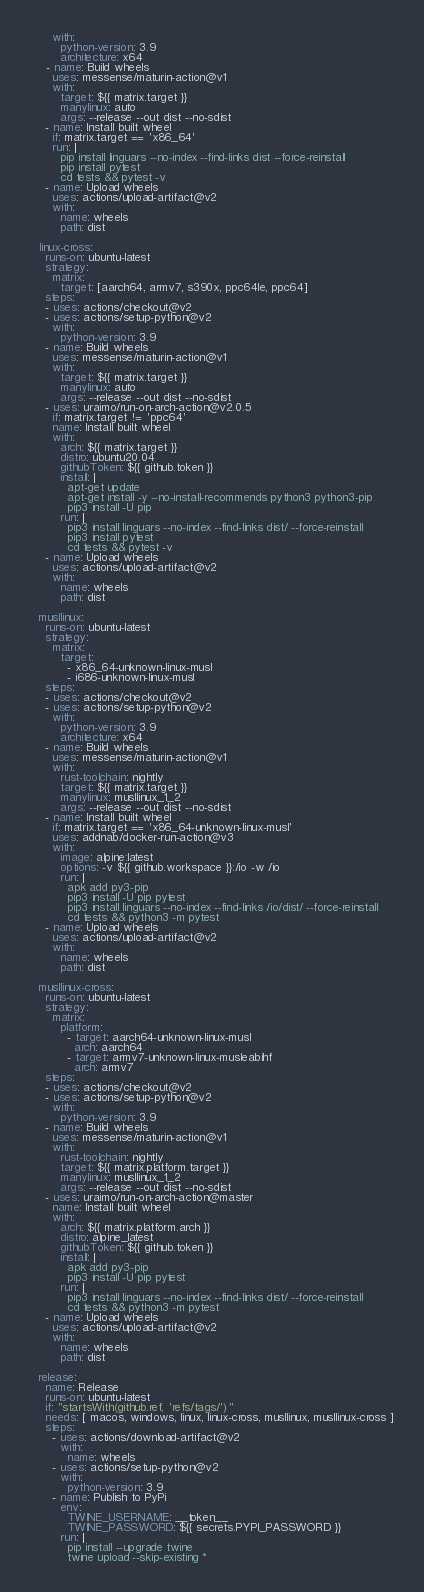Convert code to text. <code><loc_0><loc_0><loc_500><loc_500><_YAML_>      with:
        python-version: 3.9
        architecture: x64
    - name: Build wheels
      uses: messense/maturin-action@v1
      with:
        target: ${{ matrix.target }}
        manylinux: auto
        args: --release --out dist --no-sdist
    - name: Install built wheel
      if: matrix.target == 'x86_64'
      run: |
        pip install linguars --no-index --find-links dist --force-reinstall
        pip install pytest
        cd tests && pytest -v
    - name: Upload wheels
      uses: actions/upload-artifact@v2
      with:
        name: wheels
        path: dist

  linux-cross:
    runs-on: ubuntu-latest
    strategy:
      matrix:
        target: [aarch64, armv7, s390x, ppc64le, ppc64]
    steps:
    - uses: actions/checkout@v2
    - uses: actions/setup-python@v2
      with:
        python-version: 3.9
    - name: Build wheels
      uses: messense/maturin-action@v1
      with:
        target: ${{ matrix.target }}
        manylinux: auto
        args: --release --out dist --no-sdist
    - uses: uraimo/run-on-arch-action@v2.0.5
      if: matrix.target != 'ppc64'
      name: Install built wheel
      with:
        arch: ${{ matrix.target }}
        distro: ubuntu20.04
        githubToken: ${{ github.token }}
        install: |
          apt-get update
          apt-get install -y --no-install-recommends python3 python3-pip
          pip3 install -U pip
        run: |
          pip3 install linguars --no-index --find-links dist/ --force-reinstall
          pip3 install pytest
          cd tests && pytest -v
    - name: Upload wheels
      uses: actions/upload-artifact@v2
      with:
        name: wheels
        path: dist

  musllinux:
    runs-on: ubuntu-latest
    strategy:
      matrix:
        target:
          - x86_64-unknown-linux-musl
          - i686-unknown-linux-musl
    steps:
    - uses: actions/checkout@v2
    - uses: actions/setup-python@v2
      with:
        python-version: 3.9
        architecture: x64
    - name: Build wheels
      uses: messense/maturin-action@v1
      with:
        rust-toolchain: nightly
        target: ${{ matrix.target }}
        manylinux: musllinux_1_2
        args: --release --out dist --no-sdist
    - name: Install built wheel
      if: matrix.target == 'x86_64-unknown-linux-musl'
      uses: addnab/docker-run-action@v3
      with:
        image: alpine:latest
        options: -v ${{ github.workspace }}:/io -w /io
        run: |
          apk add py3-pip
          pip3 install -U pip pytest
          pip3 install linguars --no-index --find-links /io/dist/ --force-reinstall
          cd tests && python3 -m pytest
    - name: Upload wheels
      uses: actions/upload-artifact@v2
      with:
        name: wheels
        path: dist

  musllinux-cross:
    runs-on: ubuntu-latest
    strategy:
      matrix:
        platform:
          - target: aarch64-unknown-linux-musl
            arch: aarch64
          - target: armv7-unknown-linux-musleabihf
            arch: armv7
    steps:
    - uses: actions/checkout@v2
    - uses: actions/setup-python@v2
      with:
        python-version: 3.9
    - name: Build wheels
      uses: messense/maturin-action@v1
      with:
        rust-toolchain: nightly
        target: ${{ matrix.platform.target }}
        manylinux: musllinux_1_2
        args: --release --out dist --no-sdist
    - uses: uraimo/run-on-arch-action@master
      name: Install built wheel
      with:
        arch: ${{ matrix.platform.arch }}
        distro: alpine_latest
        githubToken: ${{ github.token }}
        install: |
          apk add py3-pip
          pip3 install -U pip pytest
        run: |
          pip3 install linguars --no-index --find-links dist/ --force-reinstall
          cd tests && python3 -m pytest
    - name: Upload wheels
      uses: actions/upload-artifact@v2
      with:
        name: wheels
        path: dist

  release:
    name: Release
    runs-on: ubuntu-latest
    if: "startsWith(github.ref, 'refs/tags/')"
    needs: [ macos, windows, linux, linux-cross, musllinux, musllinux-cross ]
    steps:
      - uses: actions/download-artifact@v2
        with:
          name: wheels
      - uses: actions/setup-python@v2
        with:
          python-version: 3.9
      - name: Publish to PyPi
        env:
          TWINE_USERNAME: __token__
          TWINE_PASSWORD: ${{ secrets.PYPI_PASSWORD }}
        run: |
          pip install --upgrade twine
          twine upload --skip-existing *
</code> 